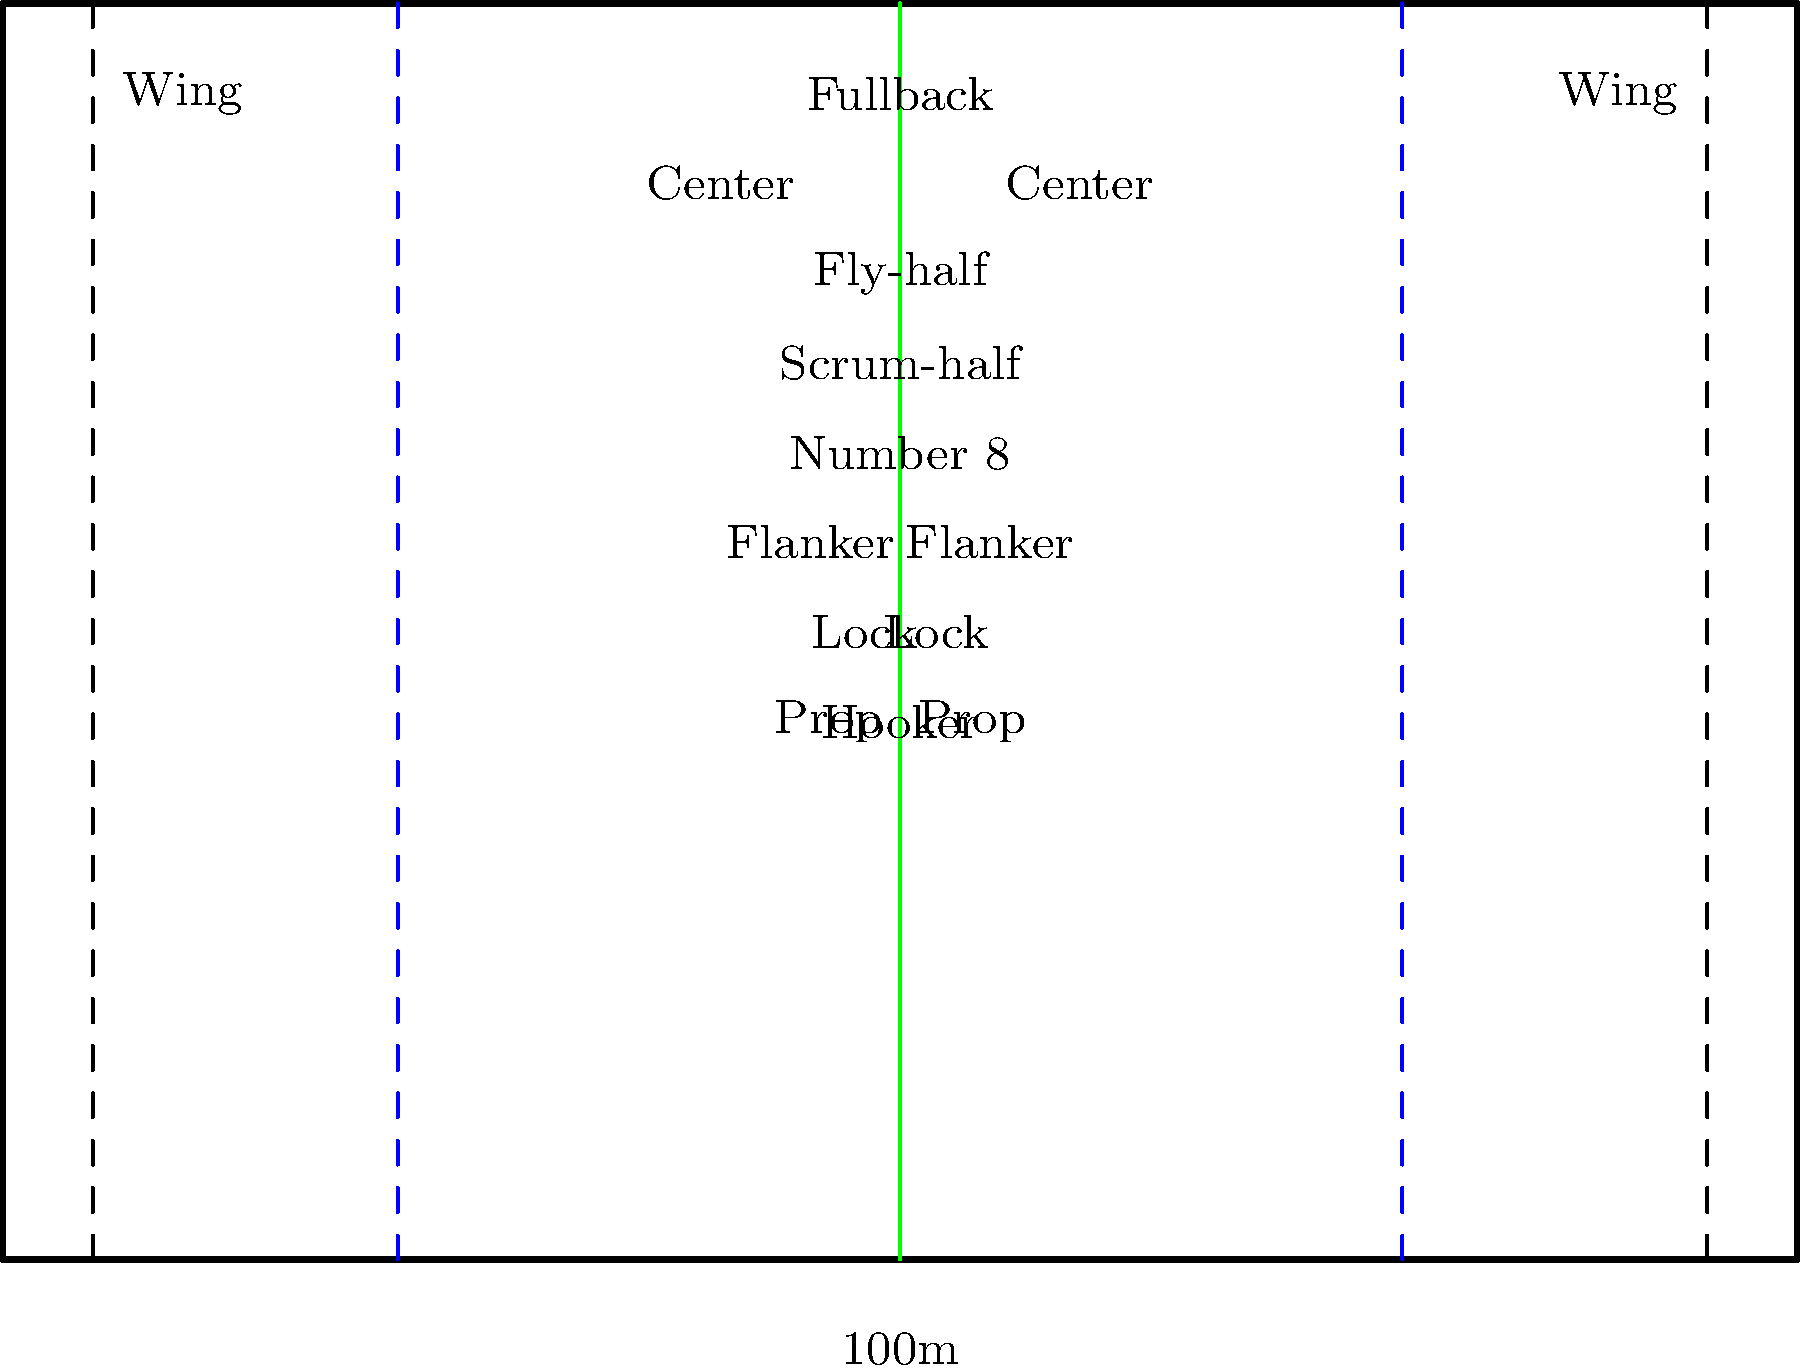As a rugby enthusiast, you're familiar with the field dimensions and player positions. In the diagram, the blue dashed lines represent the 22-meter lines. How far are these lines from each try line, and what is the total distance between the two 22-meter lines? To answer this question, let's break it down step-by-step:

1. First, recall that a rugby field is 100 meters long from try line to try line.

2. The try lines are represented by the dashed lines at each end of the field.

3. The blue dashed lines represent the 22-meter lines.

4. To find the distance of the 22-meter line from the try line:
   - The name "22-meter line" indicates that it is 22 meters from the try line.

5. To calculate the total distance between the two 22-meter lines:
   - Total field length = 100 meters
   - Distance from try line to 22-meter line on each end = 22 meters
   - Distance between 22-meter lines = Total length - (2 × 22 meters)
   - Distance between 22-meter lines = 100 - 44 = 56 meters

Therefore, the 22-meter lines are 22 meters from each try line, and the total distance between the two 22-meter lines is 56 meters.
Answer: 22 meters from try lines; 56 meters between 22-meter lines 